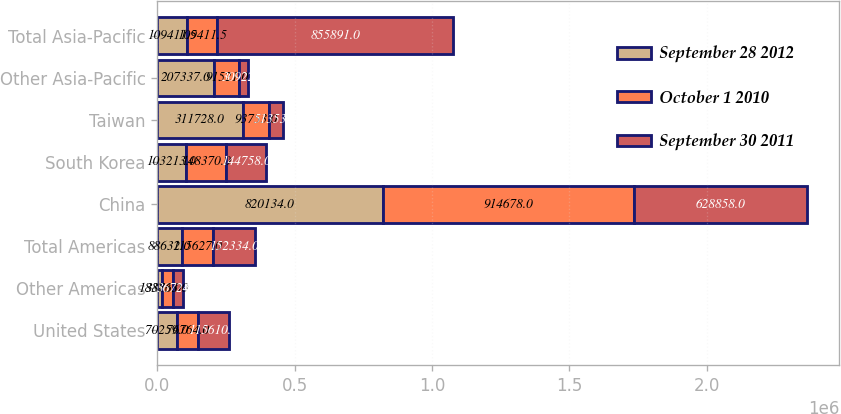Convert chart. <chart><loc_0><loc_0><loc_500><loc_500><stacked_bar_chart><ecel><fcel>United States<fcel>Other Americas<fcel>Total Americas<fcel>China<fcel>South Korea<fcel>Taiwan<fcel>Other Asia-Pacific<fcel>Total Asia-Pacific<nl><fcel>September 28 2012<fcel>70259<fcel>18373<fcel>88632<fcel>820134<fcel>103213<fcel>311728<fcel>207337<fcel>109412<nl><fcel>October 1 2010<fcel>76764<fcel>38863<fcel>115627<fcel>914678<fcel>148370<fcel>93753<fcel>91521<fcel>109412<nl><fcel>September 30 2011<fcel>115610<fcel>36724<fcel>152334<fcel>628858<fcel>144758<fcel>51353<fcel>30922<fcel>855891<nl></chart> 